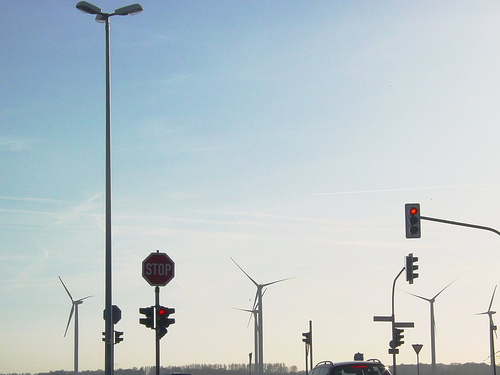Please transcribe the text in this image. STOP 